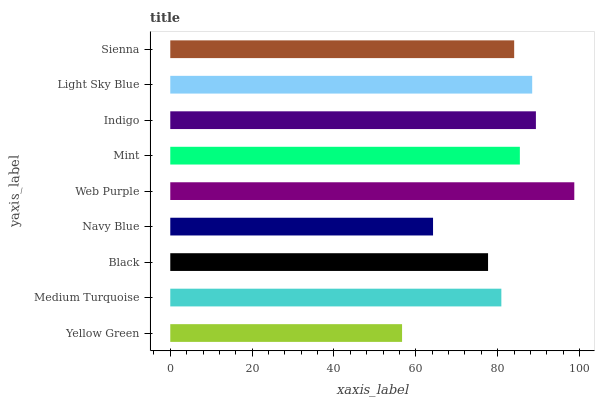Is Yellow Green the minimum?
Answer yes or no. Yes. Is Web Purple the maximum?
Answer yes or no. Yes. Is Medium Turquoise the minimum?
Answer yes or no. No. Is Medium Turquoise the maximum?
Answer yes or no. No. Is Medium Turquoise greater than Yellow Green?
Answer yes or no. Yes. Is Yellow Green less than Medium Turquoise?
Answer yes or no. Yes. Is Yellow Green greater than Medium Turquoise?
Answer yes or no. No. Is Medium Turquoise less than Yellow Green?
Answer yes or no. No. Is Sienna the high median?
Answer yes or no. Yes. Is Sienna the low median?
Answer yes or no. Yes. Is Light Sky Blue the high median?
Answer yes or no. No. Is Indigo the low median?
Answer yes or no. No. 